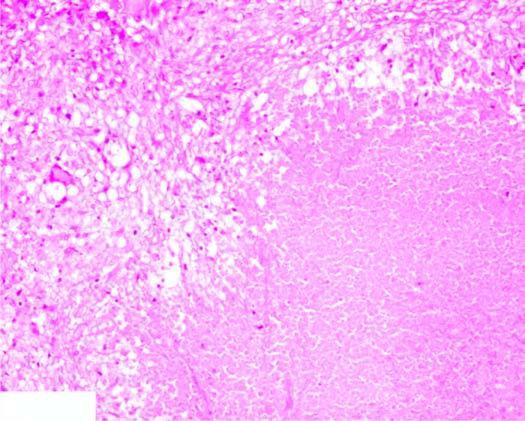s the interface between viable and non-viable area eosinophilic, amorphous, granular material, while the periphery shows granulomatous inflammation?
Answer the question using a single word or phrase. No 